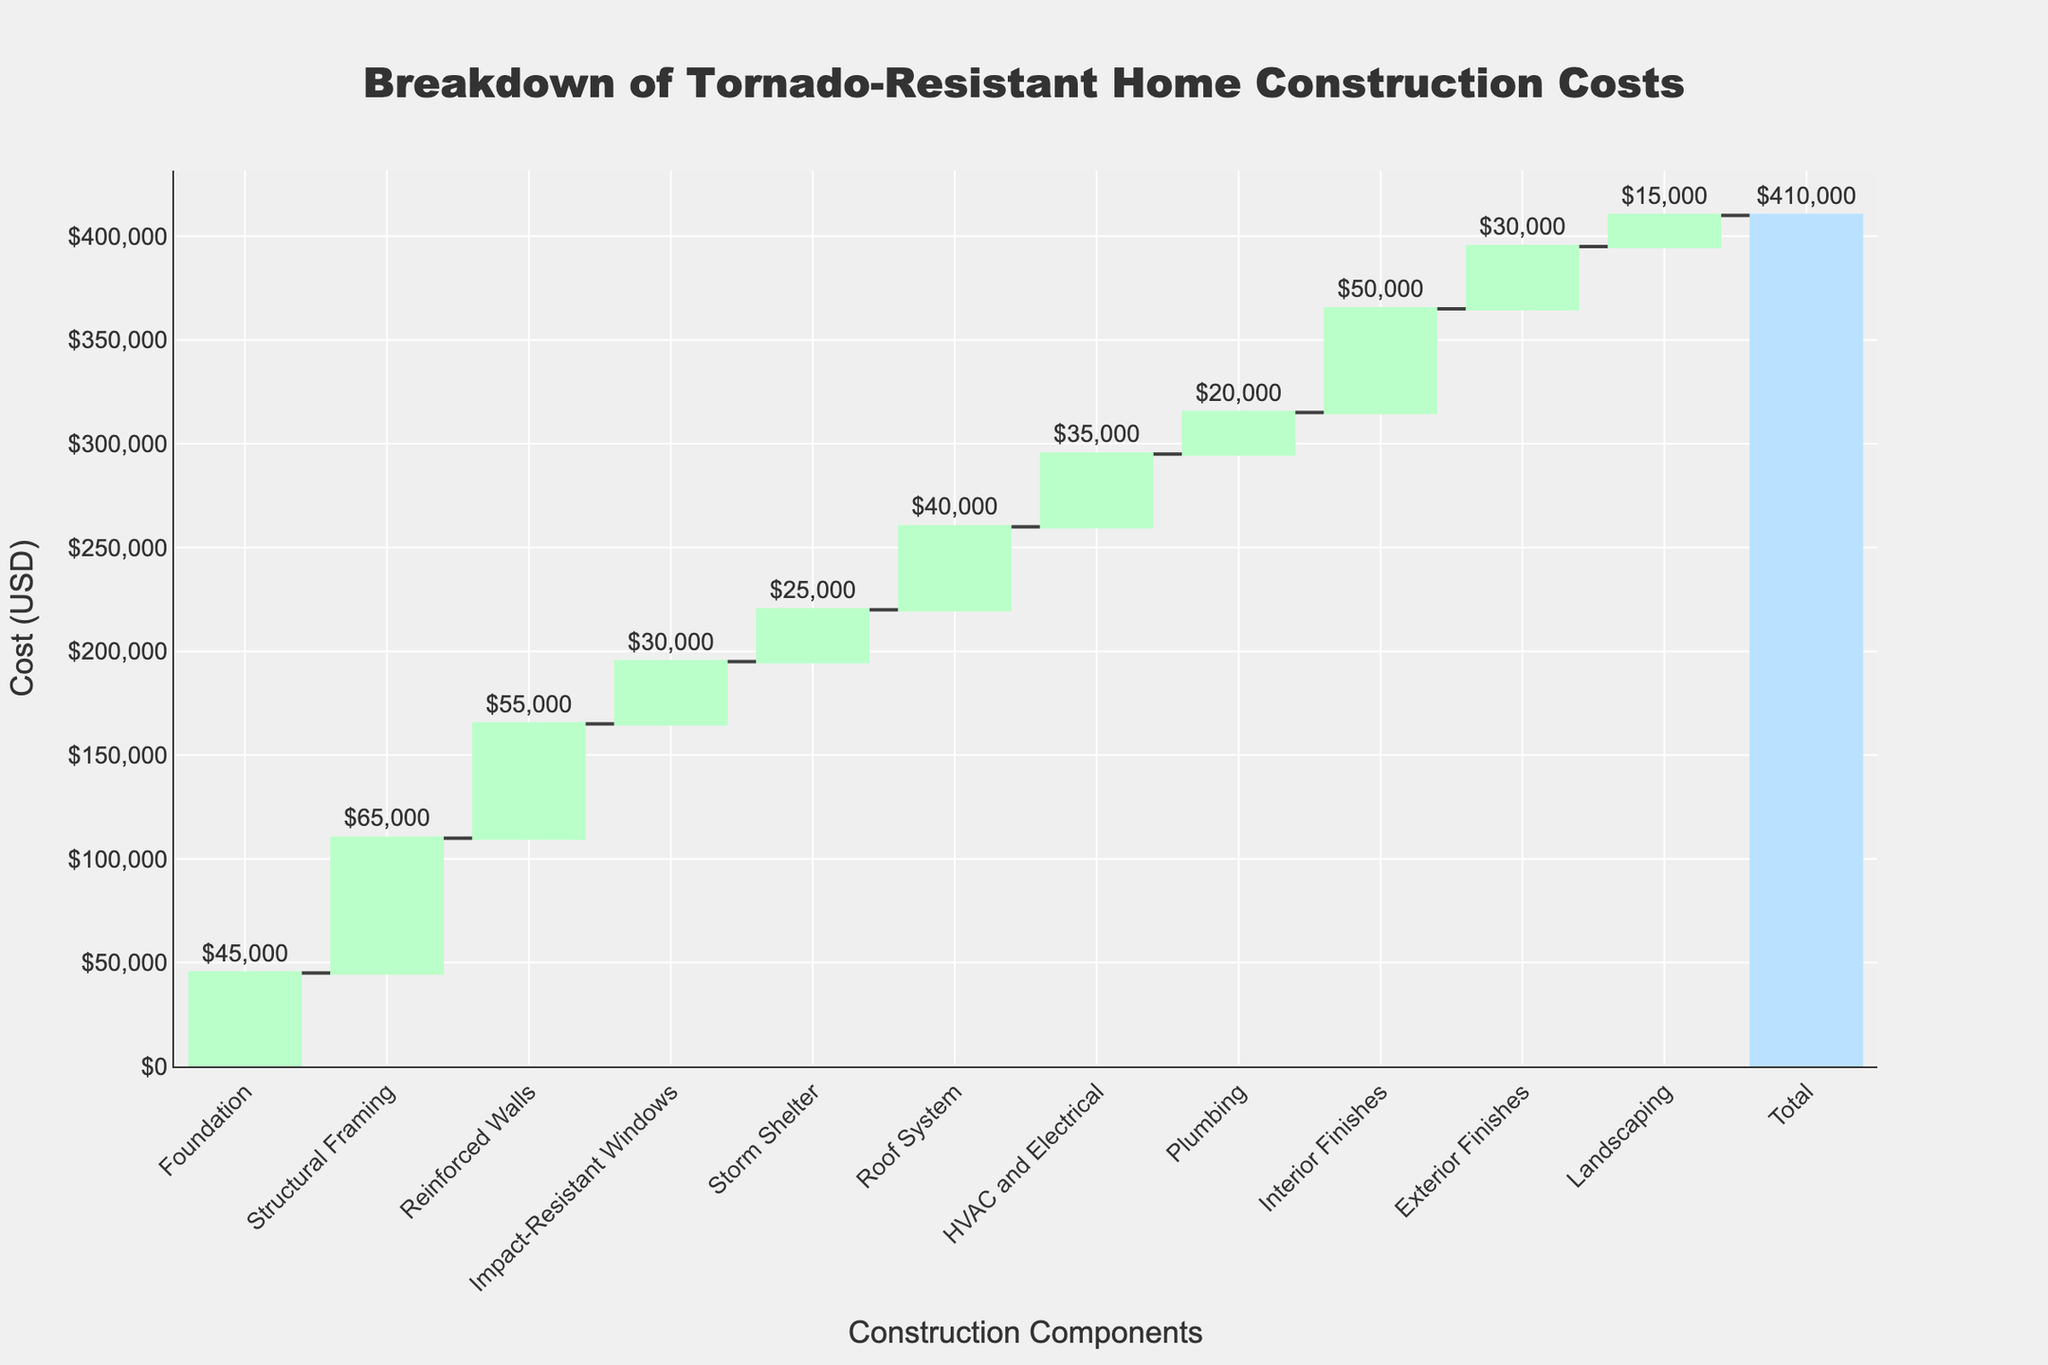What's the title of the chart? The title is typically located at the top center of the chart and is meant to describe the main subject. In this case, it is clearly stated at the top.
Answer: Breakdown of Tornado-Resistant Home Construction Costs How much does the foundation cost? The foundation cost is indicated as one of the first components in the waterfall chart, with its respective monetary value outside of its bar.
Answer: $45,000 What is the total cost of constructing the tornado-resistant home? The total cost is usually marked at the end of the waterfall chart and labeled as "Total" with the monetary value outside of the bar.
Answer: $410,000 Which construction component has the highest cost? By visually comparing the heights of the bars representing each component, it is clear that the highest bar is indicative of the highest cost.
Answer: Structural Framing ($65,000) Which two components have the same cost and what are they? By observing the bars and their values, it is possible to identify any components that have the same height/value.
Answer: Interior Finishes and Roof System ($40,000 each) What is the combined cost of the Reinforced Walls and Impact-Resistant Windows? Adding the individual costs of these two components together: $55,000 (Reinforced Walls) + $30,000 (Impact-Resistant Windows).
Answer: $85,000 How much more does the Structural Framing cost compared to the Plumbing? Subtract the cost of Plumbing from the cost of Structural Framing: $65,000 (Structural Framing) - $20,000 (Plumbing).
Answer: $45,000 more What is the average cost of the HVAC and Electrical, Plumbing, and Interior Finishes? Add the costs of these components and divide by the number of components: ($35,000 + $20,000 + $50,000) / 3.
Answer: $35,000 By how much does the cost of the Storm Shelter exceed the Landscaping cost? Subtract the cost of Landscaping from the cost of the Storm Shelter: $25,000 (Storm Shelter) - $15,000 (Landscaping).
Answer: $10,000 